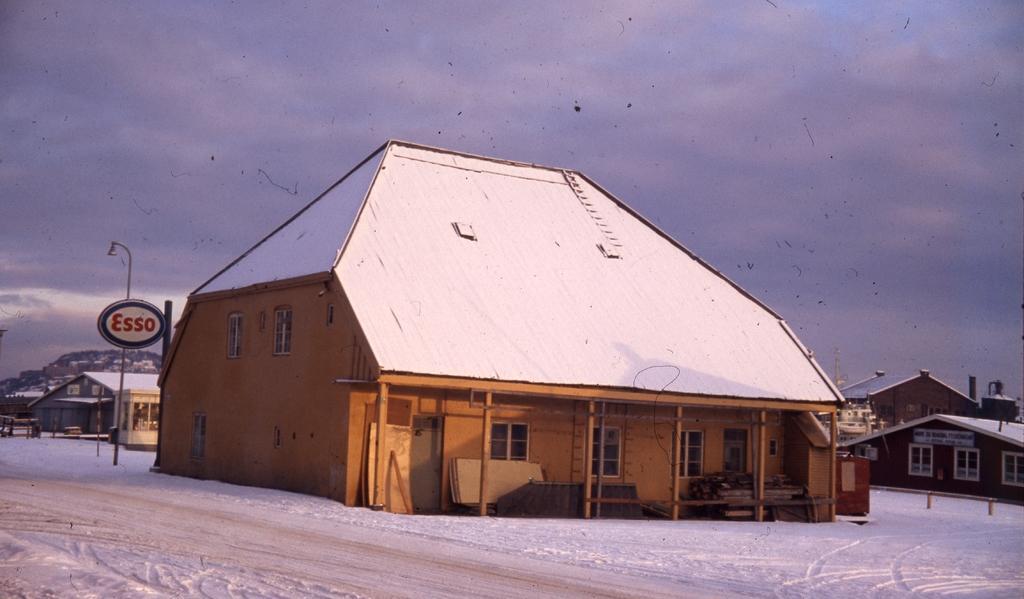Describe this image in one or two sentences. Here in this picture we can see house present here and there on the ground, which is fully covered with snow over there and we can also see hoardings and light posts here and there and we can see the sky is fully covered with clouds over there. 